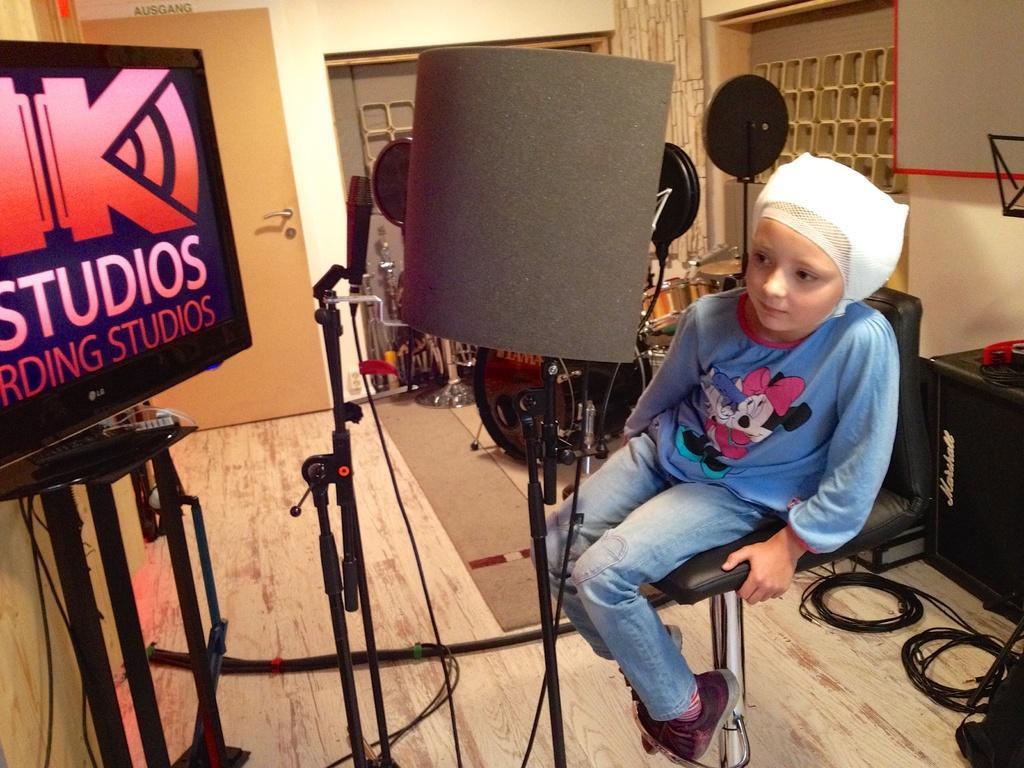Could you give a brief overview of what you see in this image? Here we can see a child sitting on a chair and in front of her we can see voice filters and microphone present 